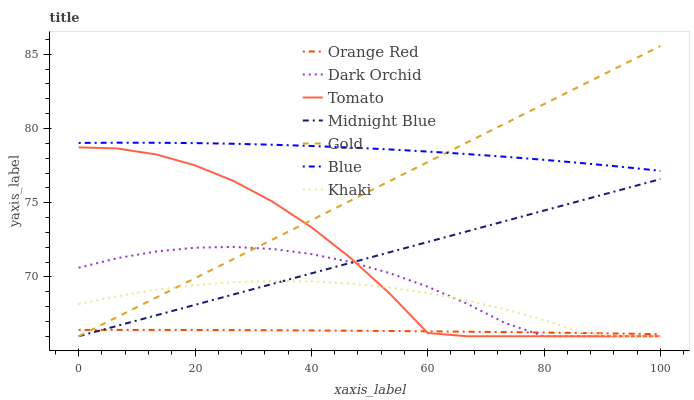Does Orange Red have the minimum area under the curve?
Answer yes or no. Yes. Does Blue have the maximum area under the curve?
Answer yes or no. Yes. Does Khaki have the minimum area under the curve?
Answer yes or no. No. Does Khaki have the maximum area under the curve?
Answer yes or no. No. Is Midnight Blue the smoothest?
Answer yes or no. Yes. Is Tomato the roughest?
Answer yes or no. Yes. Is Blue the smoothest?
Answer yes or no. No. Is Blue the roughest?
Answer yes or no. No. Does Tomato have the lowest value?
Answer yes or no. Yes. Does Blue have the lowest value?
Answer yes or no. No. Does Gold have the highest value?
Answer yes or no. Yes. Does Blue have the highest value?
Answer yes or no. No. Is Midnight Blue less than Blue?
Answer yes or no. Yes. Is Blue greater than Khaki?
Answer yes or no. Yes. Does Gold intersect Dark Orchid?
Answer yes or no. Yes. Is Gold less than Dark Orchid?
Answer yes or no. No. Is Gold greater than Dark Orchid?
Answer yes or no. No. Does Midnight Blue intersect Blue?
Answer yes or no. No. 